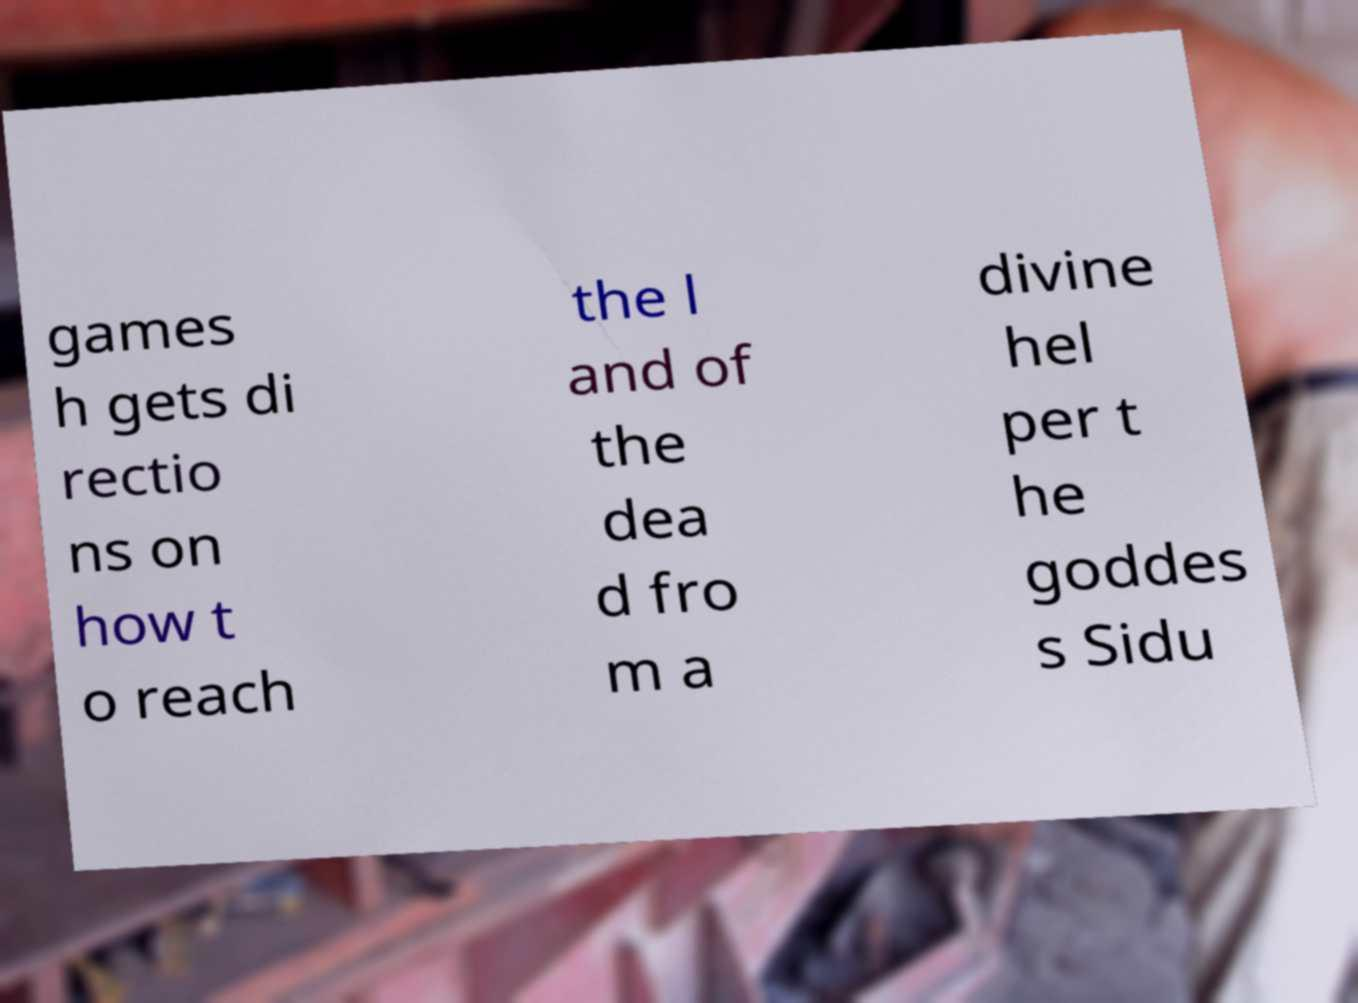Please identify and transcribe the text found in this image. games h gets di rectio ns on how t o reach the l and of the dea d fro m a divine hel per t he goddes s Sidu 